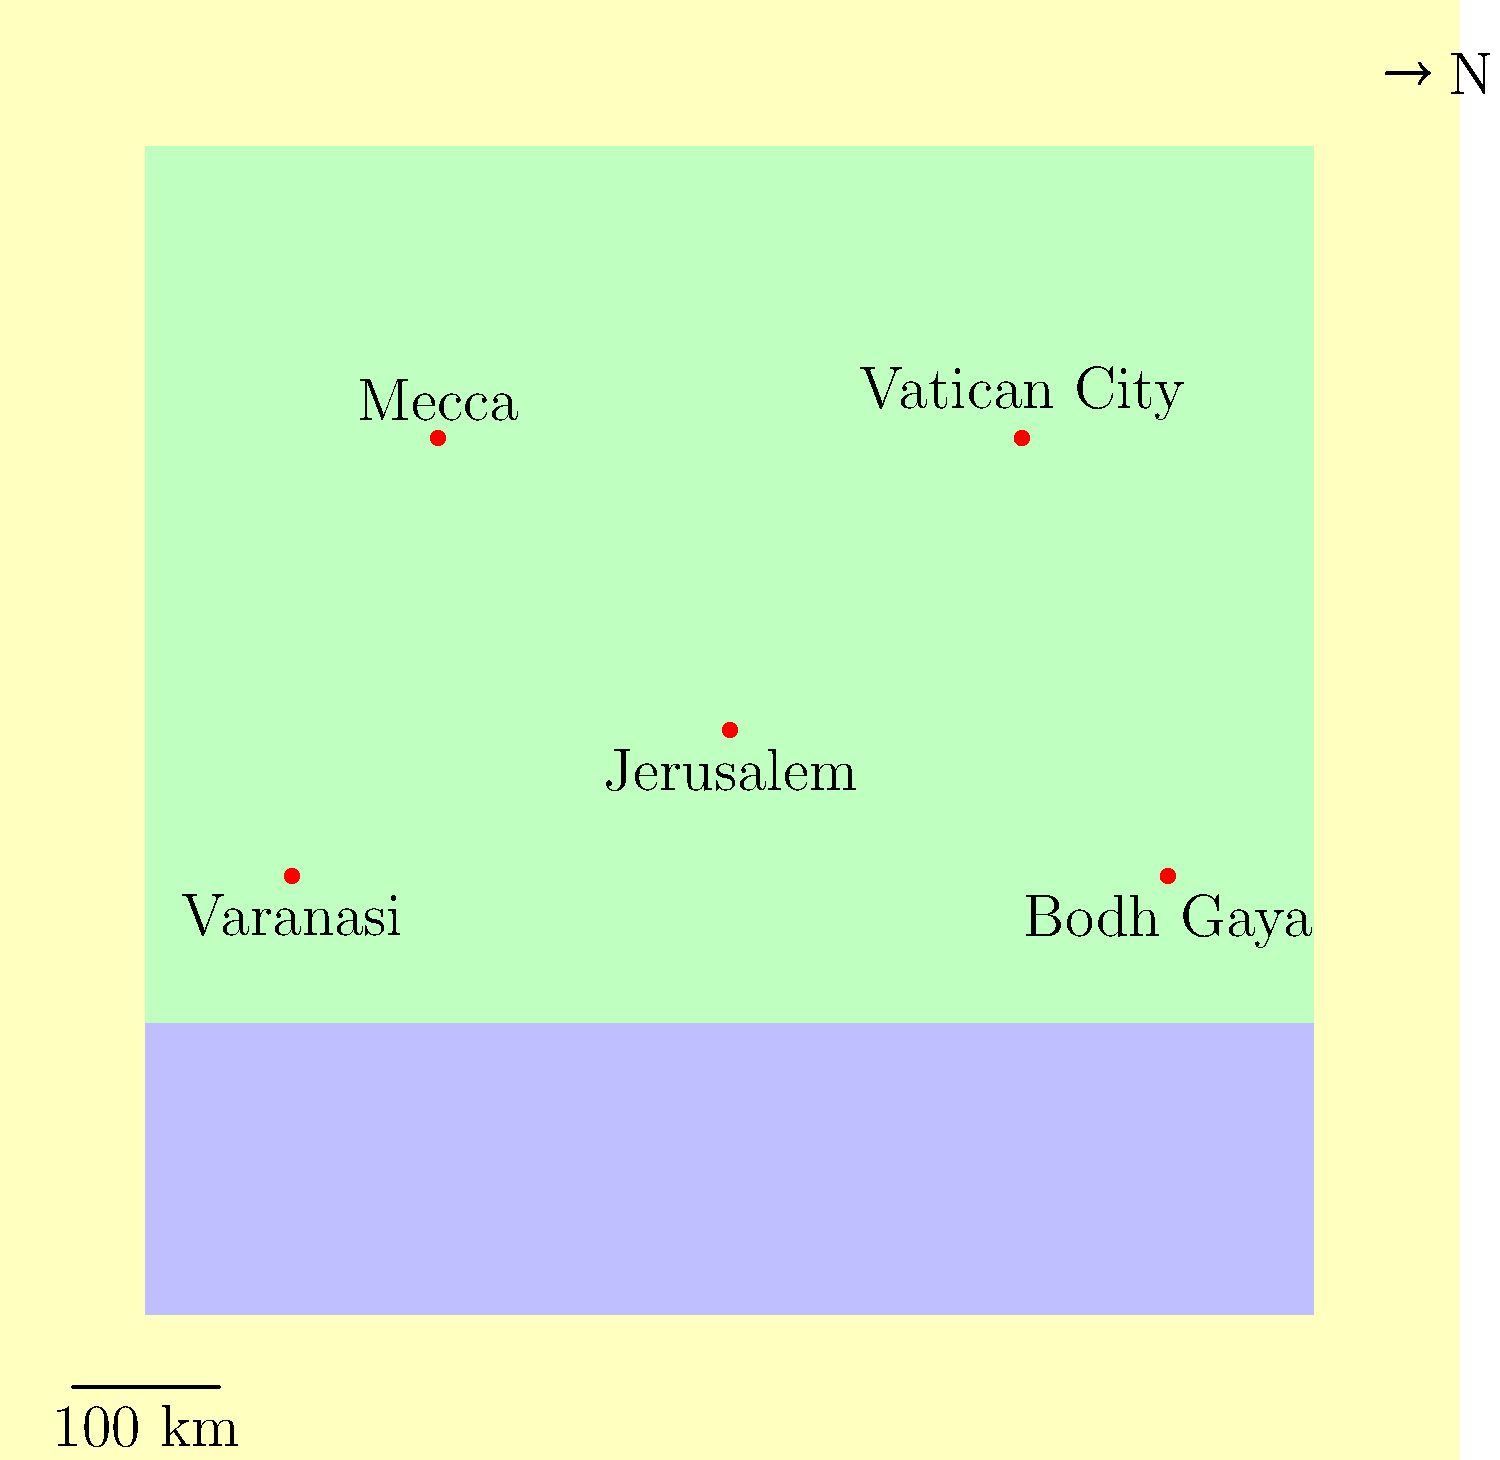In creating a map of important religious sites for our new publication "Sacred Journeys: A Global Pilgrimage Guide," which iconic landmark should be placed at the center (0,0) coordinate to represent the convergence of multiple faiths? To answer this question, let's consider the significance of each religious site shown on the map:

1. Jerusalem (0,0): Located at the center of the map, Jerusalem is a holy city for three major monotheistic religions: Judaism, Christianity, and Islam. It contains important sites such as the Western Wall, the Church of the Holy Sepulchre, and the Dome of the Rock.

2. Vatican City (2,2): The headquarters of the Roman Catholic Church and home to St. Peter's Basilica, it is significant primarily for Catholics.

3. Mecca (-2,2): The holiest city in Islam, known for the Kaaba and the annual Hajj pilgrimage.

4. Bodh Gaya (3,-1): A important site for Buddhists, where Buddha is said to have attained enlightenment.

5. Varanasi (-3,-1): A holy city for Hindus, famous for its ghats along the Ganges River.

Among these sites, Jerusalem stands out as the only one that holds significance for multiple major world religions. Its central position on the map at (0,0) symbolizes its role as a convergence point for different faiths, making it the most suitable choice for representing the theme of a global pilgrimage guide that encompasses various religions.
Answer: Jerusalem 